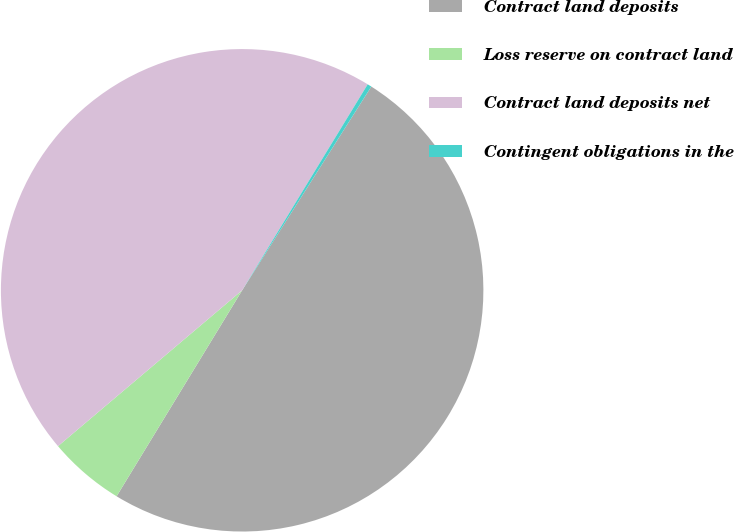Convert chart. <chart><loc_0><loc_0><loc_500><loc_500><pie_chart><fcel>Contract land deposits<fcel>Loss reserve on contract land<fcel>Contract land deposits net<fcel>Contingent obligations in the<nl><fcel>49.72%<fcel>5.11%<fcel>44.89%<fcel>0.28%<nl></chart> 